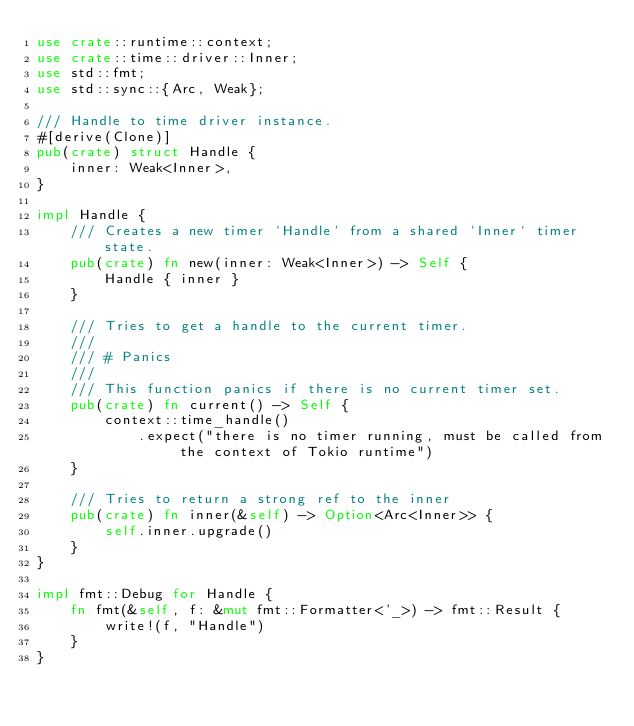Convert code to text. <code><loc_0><loc_0><loc_500><loc_500><_Rust_>use crate::runtime::context;
use crate::time::driver::Inner;
use std::fmt;
use std::sync::{Arc, Weak};

/// Handle to time driver instance.
#[derive(Clone)]
pub(crate) struct Handle {
    inner: Weak<Inner>,
}

impl Handle {
    /// Creates a new timer `Handle` from a shared `Inner` timer state.
    pub(crate) fn new(inner: Weak<Inner>) -> Self {
        Handle { inner }
    }

    /// Tries to get a handle to the current timer.
    ///
    /// # Panics
    ///
    /// This function panics if there is no current timer set.
    pub(crate) fn current() -> Self {
        context::time_handle()
            .expect("there is no timer running, must be called from the context of Tokio runtime")
    }

    /// Tries to return a strong ref to the inner
    pub(crate) fn inner(&self) -> Option<Arc<Inner>> {
        self.inner.upgrade()
    }
}

impl fmt::Debug for Handle {
    fn fmt(&self, f: &mut fmt::Formatter<'_>) -> fmt::Result {
        write!(f, "Handle")
    }
}
</code> 